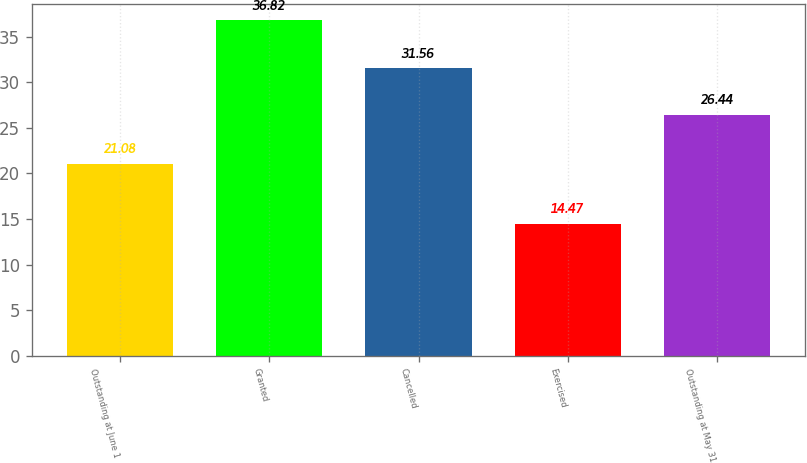Convert chart. <chart><loc_0><loc_0><loc_500><loc_500><bar_chart><fcel>Outstanding at June 1<fcel>Granted<fcel>Cancelled<fcel>Exercised<fcel>Outstanding at May 31<nl><fcel>21.08<fcel>36.82<fcel>31.56<fcel>14.47<fcel>26.44<nl></chart> 